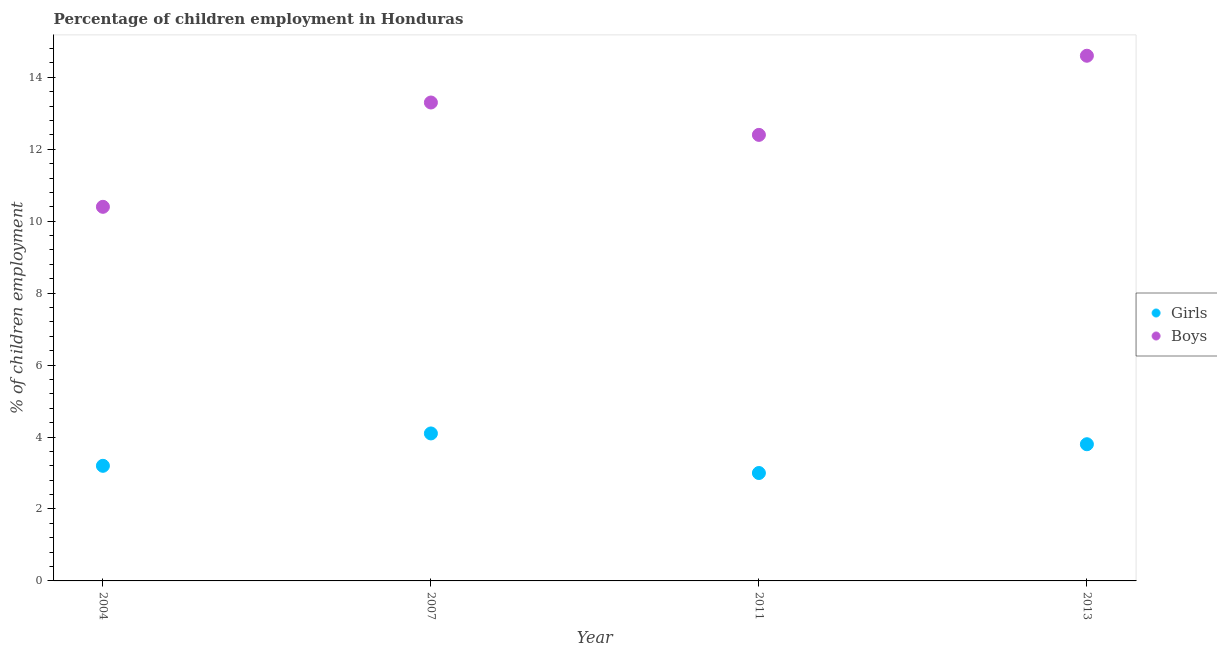Is the number of dotlines equal to the number of legend labels?
Ensure brevity in your answer.  Yes. What is the percentage of employed boys in 2007?
Your response must be concise. 13.3. What is the total percentage of employed girls in the graph?
Ensure brevity in your answer.  14.1. What is the difference between the percentage of employed girls in 2007 and that in 2011?
Give a very brief answer. 1.1. What is the difference between the percentage of employed girls in 2013 and the percentage of employed boys in 2004?
Keep it short and to the point. -6.6. What is the average percentage of employed girls per year?
Keep it short and to the point. 3.53. In how many years, is the percentage of employed girls greater than 6.8 %?
Your answer should be compact. 0. What is the ratio of the percentage of employed boys in 2004 to that in 2007?
Give a very brief answer. 0.78. Is the percentage of employed boys in 2004 less than that in 2011?
Give a very brief answer. Yes. Is the difference between the percentage of employed girls in 2011 and 2013 greater than the difference between the percentage of employed boys in 2011 and 2013?
Keep it short and to the point. Yes. What is the difference between the highest and the second highest percentage of employed girls?
Your response must be concise. 0.3. What is the difference between the highest and the lowest percentage of employed boys?
Offer a terse response. 4.2. In how many years, is the percentage of employed boys greater than the average percentage of employed boys taken over all years?
Keep it short and to the point. 2. Does the percentage of employed boys monotonically increase over the years?
Provide a succinct answer. No. Is the percentage of employed boys strictly greater than the percentage of employed girls over the years?
Your answer should be compact. Yes. Is the percentage of employed boys strictly less than the percentage of employed girls over the years?
Your response must be concise. No. How many years are there in the graph?
Give a very brief answer. 4. Are the values on the major ticks of Y-axis written in scientific E-notation?
Your answer should be very brief. No. Where does the legend appear in the graph?
Your answer should be compact. Center right. How many legend labels are there?
Provide a succinct answer. 2. What is the title of the graph?
Provide a short and direct response. Percentage of children employment in Honduras. What is the label or title of the Y-axis?
Your answer should be very brief. % of children employment. What is the % of children employment in Girls in 2007?
Provide a succinct answer. 4.1. What is the % of children employment in Boys in 2007?
Keep it short and to the point. 13.3. What is the % of children employment of Girls in 2011?
Your response must be concise. 3. Across all years, what is the maximum % of children employment of Boys?
Your answer should be very brief. 14.6. Across all years, what is the minimum % of children employment of Girls?
Give a very brief answer. 3. Across all years, what is the minimum % of children employment in Boys?
Provide a succinct answer. 10.4. What is the total % of children employment in Boys in the graph?
Offer a very short reply. 50.7. What is the difference between the % of children employment of Girls in 2011 and that in 2013?
Provide a succinct answer. -0.8. What is the difference between the % of children employment in Girls in 2004 and the % of children employment in Boys in 2007?
Give a very brief answer. -10.1. What is the difference between the % of children employment in Girls in 2004 and the % of children employment in Boys in 2011?
Keep it short and to the point. -9.2. What is the difference between the % of children employment in Girls in 2004 and the % of children employment in Boys in 2013?
Keep it short and to the point. -11.4. What is the difference between the % of children employment in Girls in 2007 and the % of children employment in Boys in 2011?
Make the answer very short. -8.3. What is the difference between the % of children employment in Girls in 2007 and the % of children employment in Boys in 2013?
Offer a very short reply. -10.5. What is the difference between the % of children employment in Girls in 2011 and the % of children employment in Boys in 2013?
Your answer should be compact. -11.6. What is the average % of children employment in Girls per year?
Your answer should be very brief. 3.52. What is the average % of children employment of Boys per year?
Your answer should be very brief. 12.68. In the year 2004, what is the difference between the % of children employment of Girls and % of children employment of Boys?
Keep it short and to the point. -7.2. In the year 2007, what is the difference between the % of children employment of Girls and % of children employment of Boys?
Give a very brief answer. -9.2. What is the ratio of the % of children employment in Girls in 2004 to that in 2007?
Give a very brief answer. 0.78. What is the ratio of the % of children employment of Boys in 2004 to that in 2007?
Your response must be concise. 0.78. What is the ratio of the % of children employment of Girls in 2004 to that in 2011?
Give a very brief answer. 1.07. What is the ratio of the % of children employment of Boys in 2004 to that in 2011?
Your answer should be very brief. 0.84. What is the ratio of the % of children employment of Girls in 2004 to that in 2013?
Make the answer very short. 0.84. What is the ratio of the % of children employment of Boys in 2004 to that in 2013?
Your response must be concise. 0.71. What is the ratio of the % of children employment of Girls in 2007 to that in 2011?
Ensure brevity in your answer.  1.37. What is the ratio of the % of children employment in Boys in 2007 to that in 2011?
Your answer should be compact. 1.07. What is the ratio of the % of children employment of Girls in 2007 to that in 2013?
Make the answer very short. 1.08. What is the ratio of the % of children employment of Boys in 2007 to that in 2013?
Offer a very short reply. 0.91. What is the ratio of the % of children employment of Girls in 2011 to that in 2013?
Provide a short and direct response. 0.79. What is the ratio of the % of children employment of Boys in 2011 to that in 2013?
Keep it short and to the point. 0.85. What is the difference between the highest and the second highest % of children employment of Girls?
Your response must be concise. 0.3. What is the difference between the highest and the second highest % of children employment in Boys?
Your response must be concise. 1.3. What is the difference between the highest and the lowest % of children employment of Girls?
Provide a succinct answer. 1.1. 